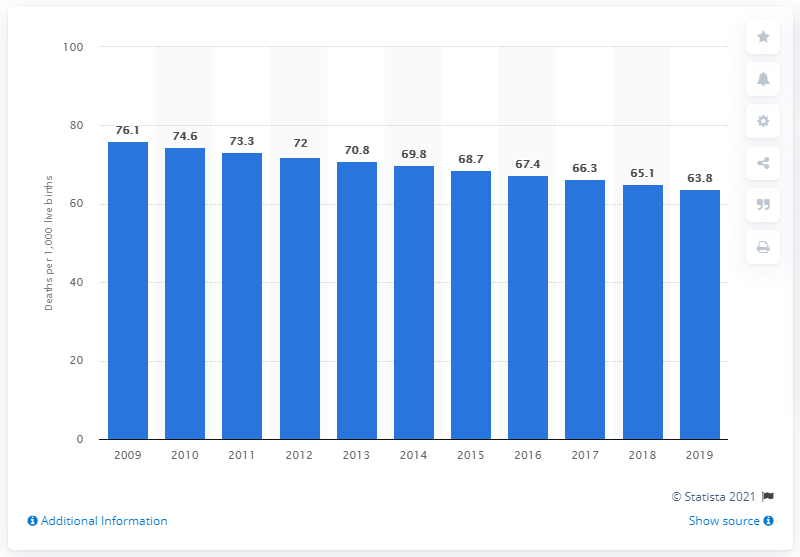Give some essential details in this illustration. In 2019, the infant mortality rate in Guinea was 63.8 deaths per 1,000 live births. 